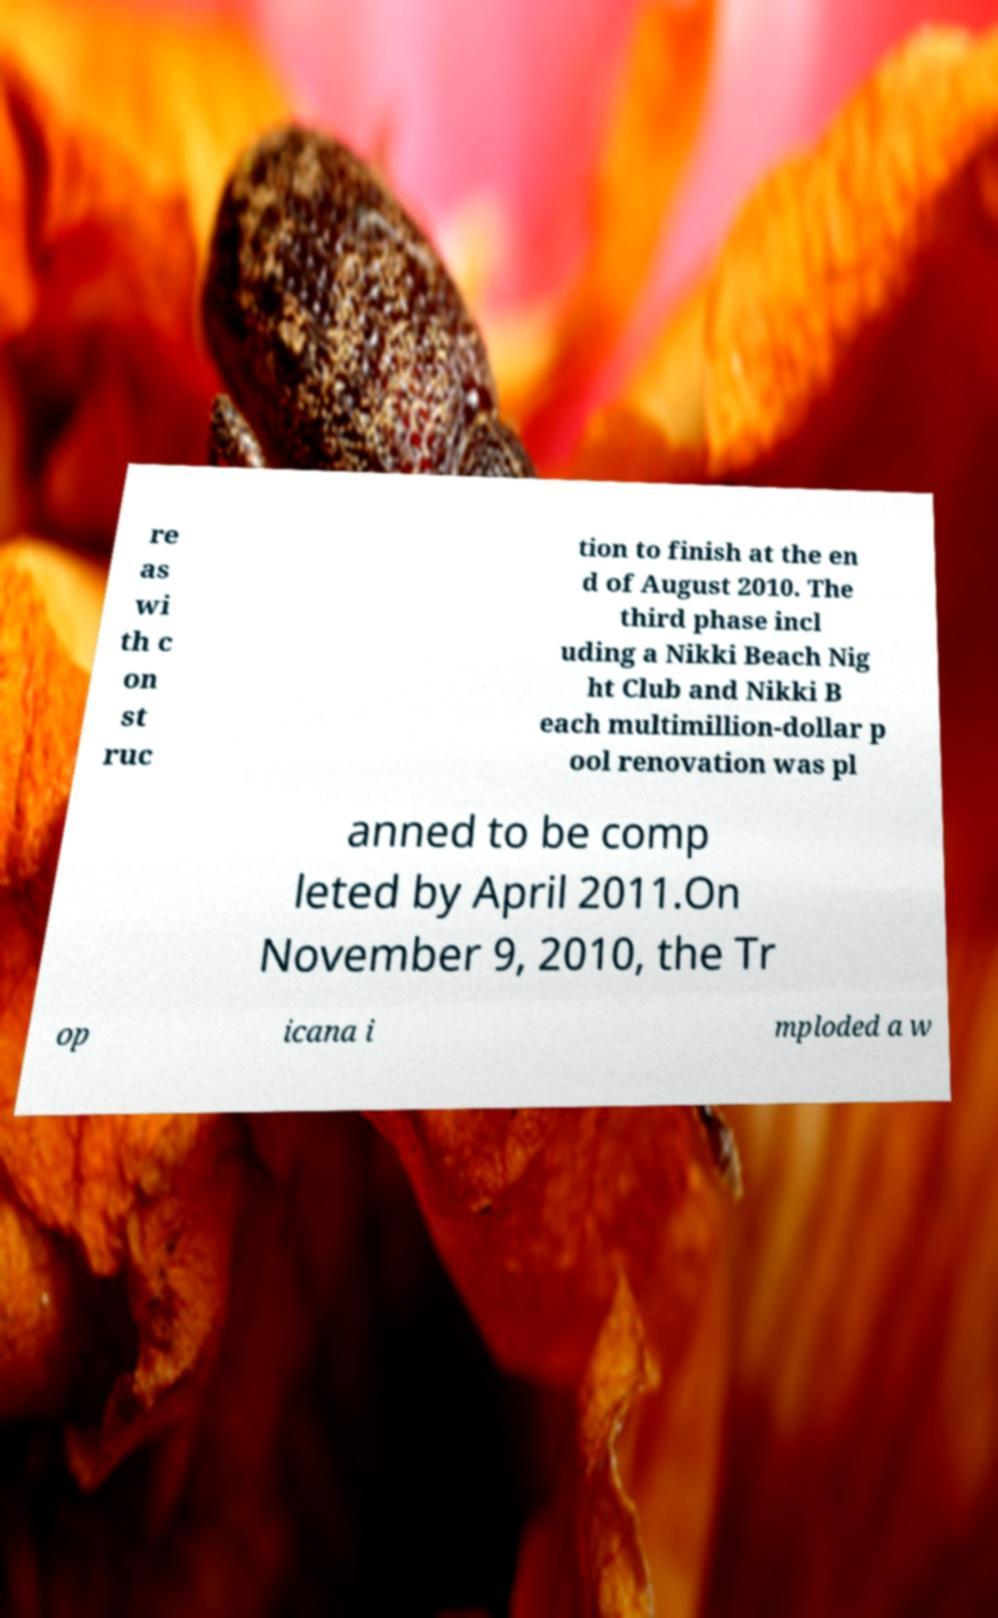Could you assist in decoding the text presented in this image and type it out clearly? re as wi th c on st ruc tion to finish at the en d of August 2010. The third phase incl uding a Nikki Beach Nig ht Club and Nikki B each multimillion-dollar p ool renovation was pl anned to be comp leted by April 2011.On November 9, 2010, the Tr op icana i mploded a w 